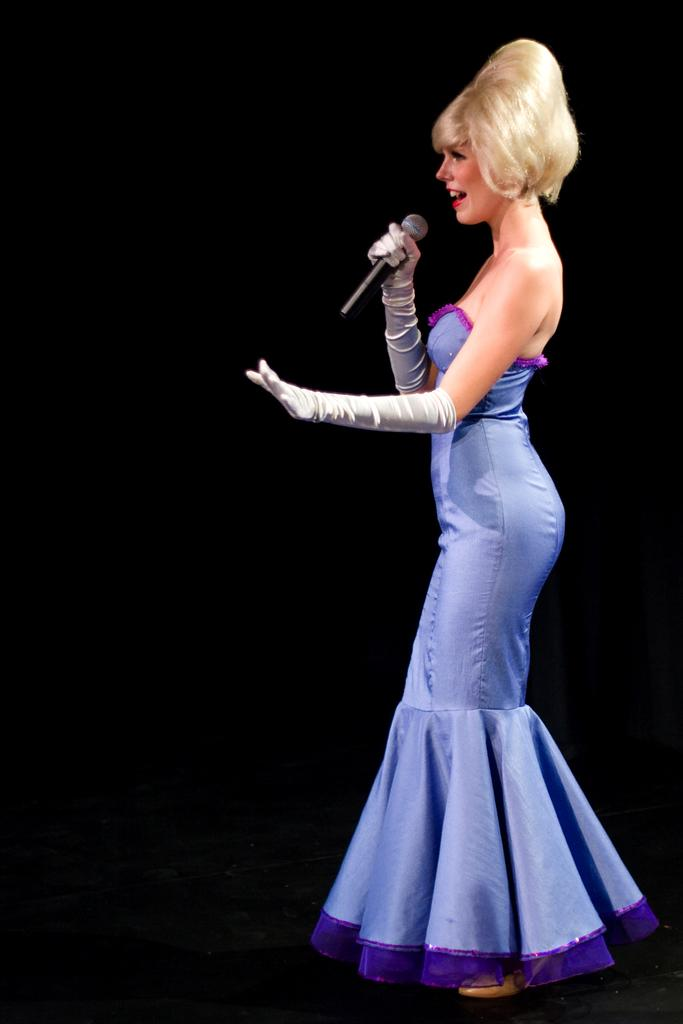What is the main subject of the image? The main subject of the image is a lady. What is the lady doing in the image? The lady is standing in the image. What object is the lady holding in the image? The lady is holding a mic in the image. What type of curve can be seen in the garden in the image? There is no garden or curve present in the image; it features a lady standing and holding a mic. 